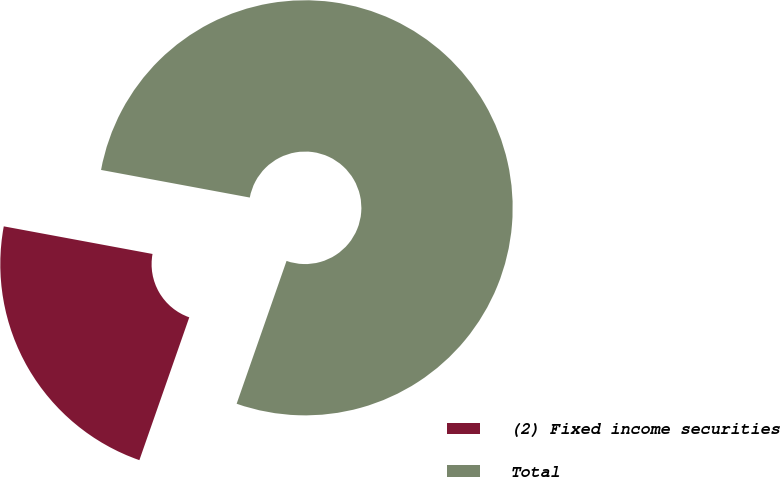Convert chart. <chart><loc_0><loc_0><loc_500><loc_500><pie_chart><fcel>(2) Fixed income securities<fcel>Total<nl><fcel>22.57%<fcel>77.43%<nl></chart> 